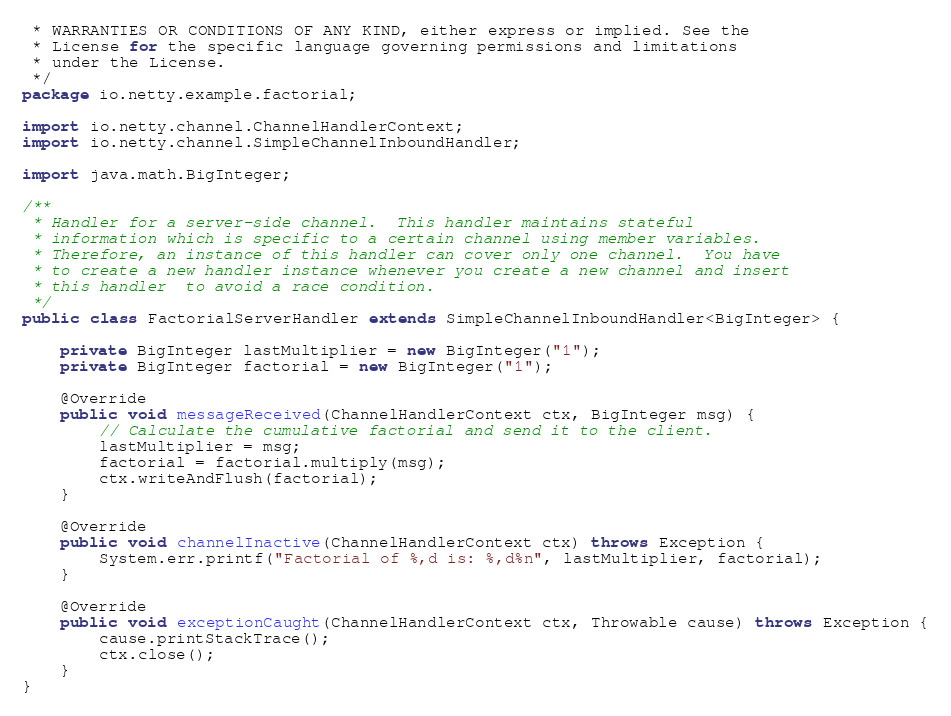Convert code to text. <code><loc_0><loc_0><loc_500><loc_500><_Java_> * WARRANTIES OR CONDITIONS OF ANY KIND, either express or implied. See the
 * License for the specific language governing permissions and limitations
 * under the License.
 */
package io.netty.example.factorial;

import io.netty.channel.ChannelHandlerContext;
import io.netty.channel.SimpleChannelInboundHandler;

import java.math.BigInteger;

/**
 * Handler for a server-side channel.  This handler maintains stateful
 * information which is specific to a certain channel using member variables.
 * Therefore, an instance of this handler can cover only one channel.  You have
 * to create a new handler instance whenever you create a new channel and insert
 * this handler  to avoid a race condition.
 */
public class FactorialServerHandler extends SimpleChannelInboundHandler<BigInteger> {

    private BigInteger lastMultiplier = new BigInteger("1");
    private BigInteger factorial = new BigInteger("1");

    @Override
    public void messageReceived(ChannelHandlerContext ctx, BigInteger msg) {
        // Calculate the cumulative factorial and send it to the client.
        lastMultiplier = msg;
        factorial = factorial.multiply(msg);
        ctx.writeAndFlush(factorial);
    }

    @Override
    public void channelInactive(ChannelHandlerContext ctx) throws Exception {
        System.err.printf("Factorial of %,d is: %,d%n", lastMultiplier, factorial);
    }

    @Override
    public void exceptionCaught(ChannelHandlerContext ctx, Throwable cause) throws Exception {
        cause.printStackTrace();
        ctx.close();
    }
}
</code> 